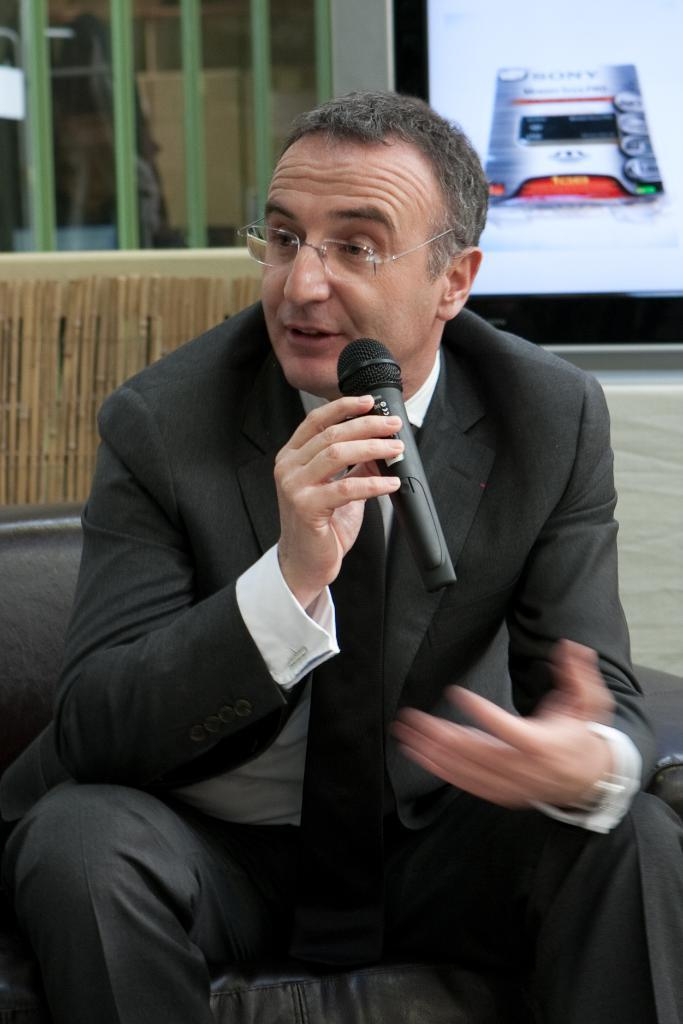What is the main subject of the image? The main subject of the image is a man. What is the man doing in the image? The man is sitting on a chair in the image. What object is the man holding in the image? The man is holding a microphone in the image. What type of wood can be seen in the image? There is no wood present in the image. Can you describe the insect that is crawling on the man's shoulder in the image? There is no insect present in the image. What type of offer is the man making to the audience in the image? There is no indication in the image that the man is making an offer to an audience. 